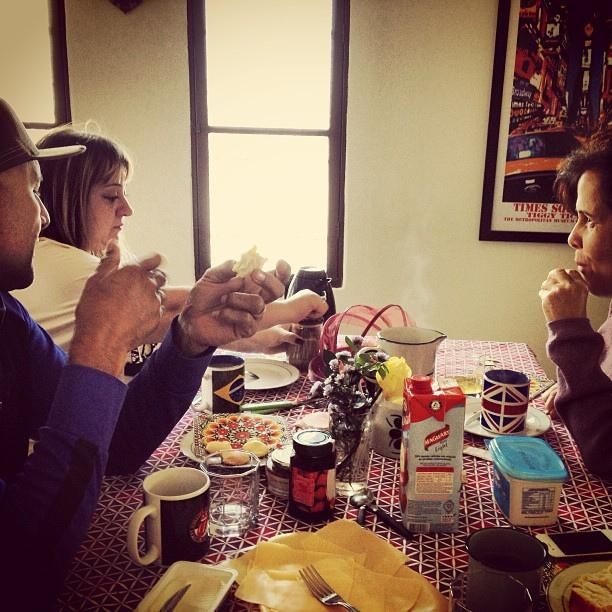Why have these people gathered?

Choices:
A) to compete
B) to eat
C) to play
D) to work to eat 